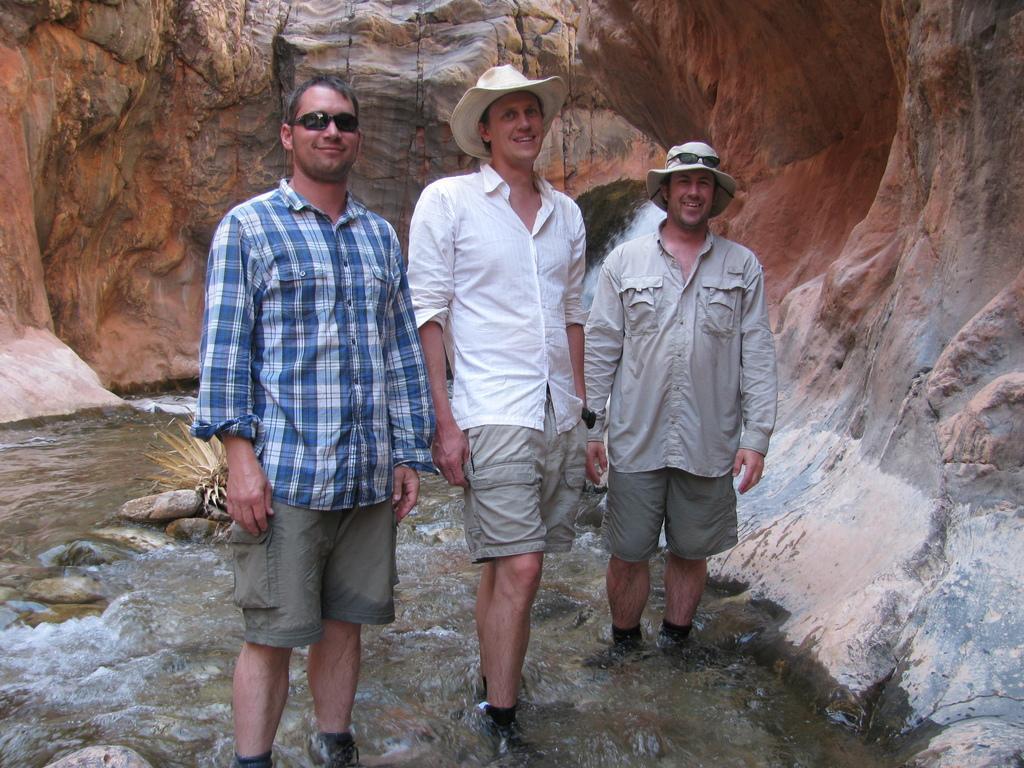Could you give a brief overview of what you see in this image? In this picture we can see three men smiling and standing in water. There is a plant and few rocks in water. We can see some rocks in the background. 